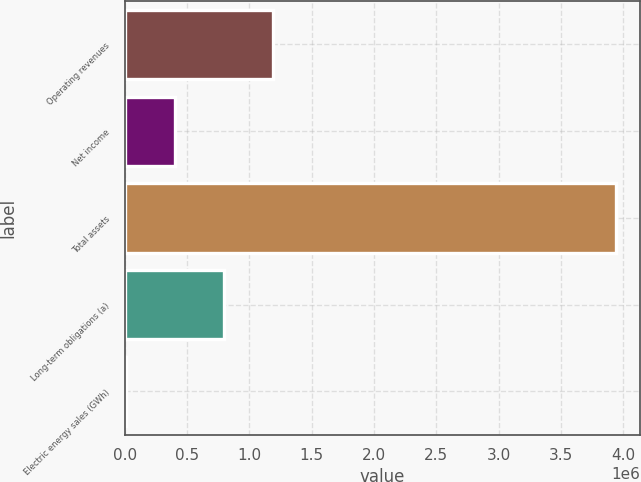Convert chart to OTSL. <chart><loc_0><loc_0><loc_500><loc_500><bar_chart><fcel>Operating revenues<fcel>Net income<fcel>Total assets<fcel>Long-term obligations (a)<fcel>Electric energy sales (GWh)<nl><fcel>1.18634e+06<fcel>399896<fcel>3.93889e+06<fcel>793117<fcel>6675<nl></chart> 